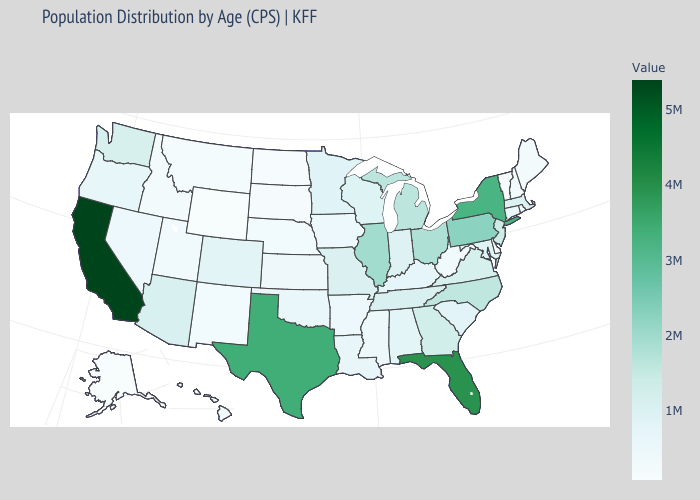Is the legend a continuous bar?
Quick response, please. Yes. Does South Carolina have a lower value than Rhode Island?
Concise answer only. No. Which states have the lowest value in the West?
Keep it brief. Alaska. Does California have the highest value in the USA?
Be succinct. Yes. 